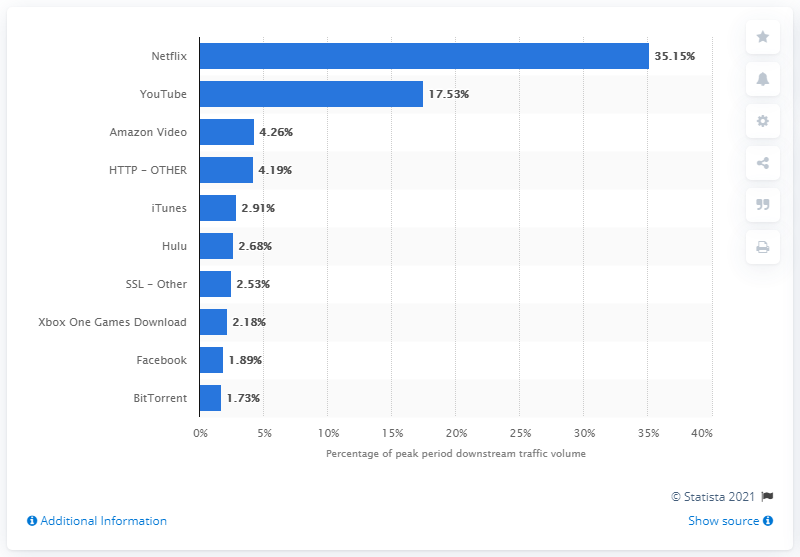Outline some significant characteristics in this image. In March 2016, Netflix accounted for over a third of the peak period downstream traffic, making it the dominant application in terms of internet traffic. 